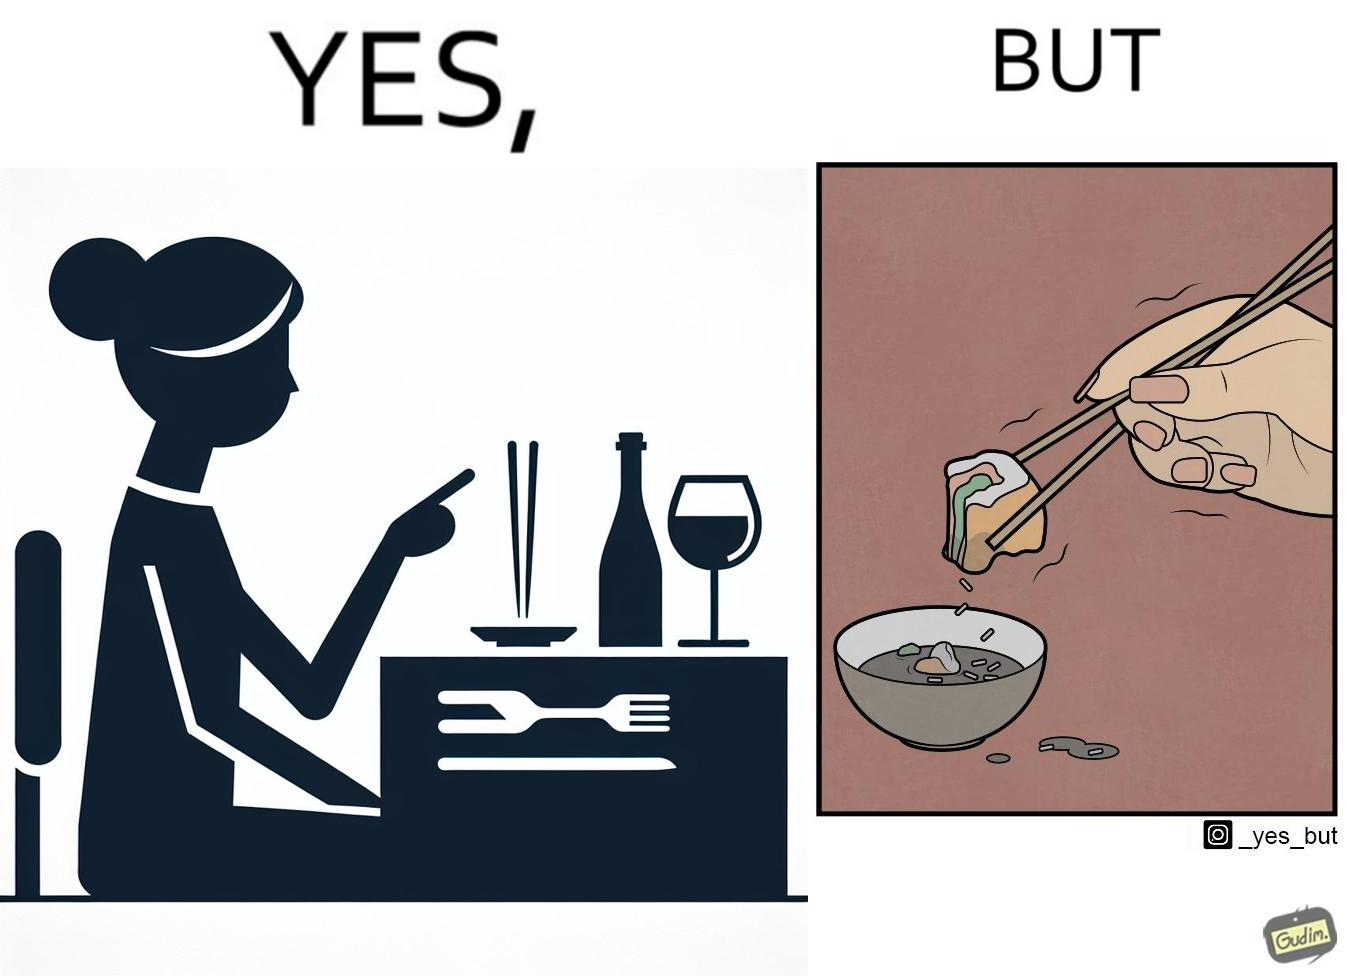Describe what you see in this image. The image is satirical because even thought the woman is not able to eat food with chopstick properly, she chooses it over fork and knife to look sophisticaed. 